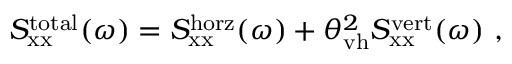<formula> <loc_0><loc_0><loc_500><loc_500>S _ { x x } ^ { t o t a l } ( \omega ) = S _ { x x } ^ { h o r z } ( \omega ) + \theta _ { v h } ^ { 2 } S _ { x x } ^ { v e r t } ( \omega ) ,</formula> 